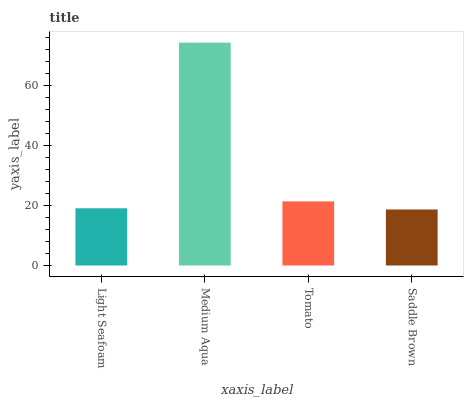Is Saddle Brown the minimum?
Answer yes or no. Yes. Is Medium Aqua the maximum?
Answer yes or no. Yes. Is Tomato the minimum?
Answer yes or no. No. Is Tomato the maximum?
Answer yes or no. No. Is Medium Aqua greater than Tomato?
Answer yes or no. Yes. Is Tomato less than Medium Aqua?
Answer yes or no. Yes. Is Tomato greater than Medium Aqua?
Answer yes or no. No. Is Medium Aqua less than Tomato?
Answer yes or no. No. Is Tomato the high median?
Answer yes or no. Yes. Is Light Seafoam the low median?
Answer yes or no. Yes. Is Saddle Brown the high median?
Answer yes or no. No. Is Saddle Brown the low median?
Answer yes or no. No. 